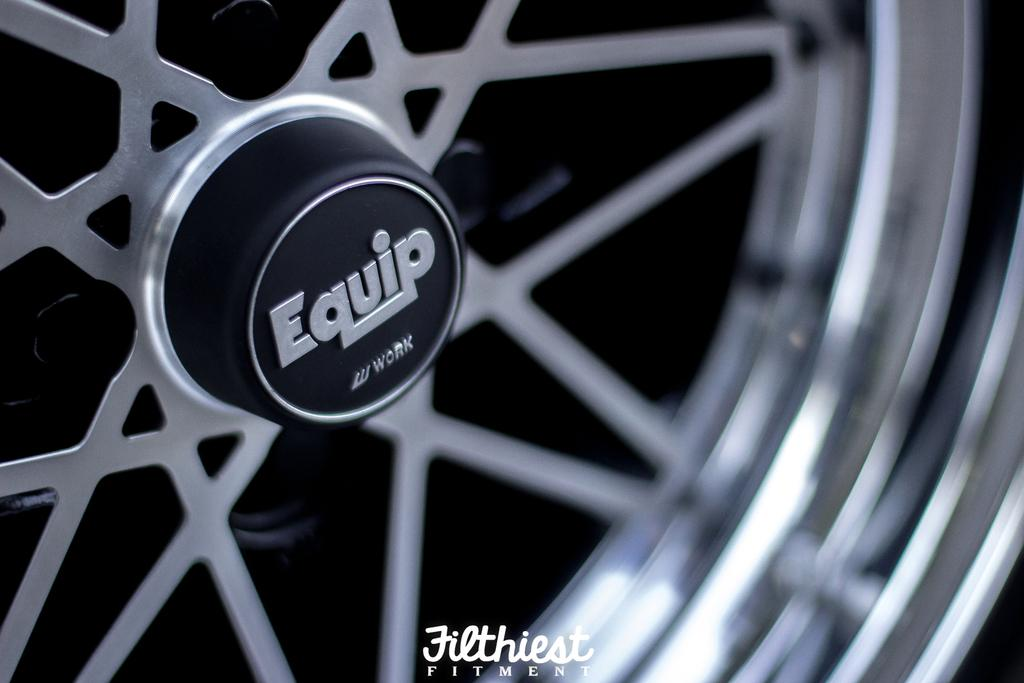What is the main subject of the image? The main subject of the image is a wheel tire. What is written on the wheel tire? The word "Equip" is written on the wheel tire. Is there any additional information or markings in the image? Yes, there is a watermark in the bottom of the image. What type of reaction can be seen from the wheel tire in the image? Wheel tires do not have the ability to react, as they are inanimate objects. 